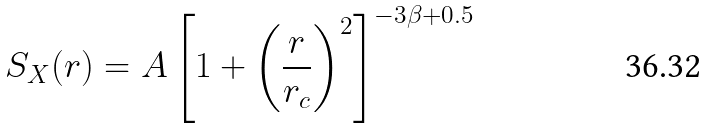<formula> <loc_0><loc_0><loc_500><loc_500>S _ { X } ( r ) = A \left [ 1 + \left ( \frac { r } { r _ { c } } \right ) ^ { 2 } \right ] ^ { - 3 \beta + 0 . 5 }</formula> 